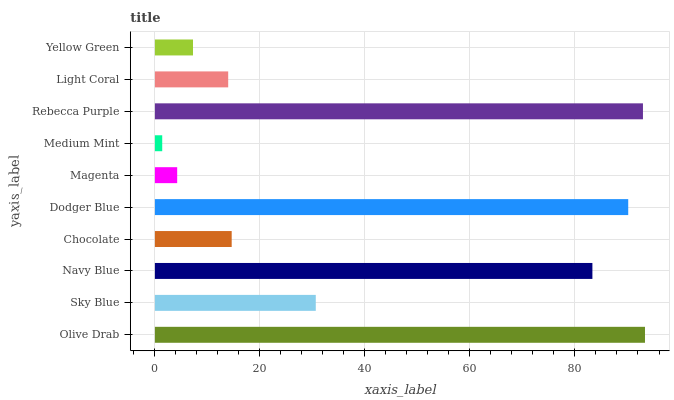Is Medium Mint the minimum?
Answer yes or no. Yes. Is Olive Drab the maximum?
Answer yes or no. Yes. Is Sky Blue the minimum?
Answer yes or no. No. Is Sky Blue the maximum?
Answer yes or no. No. Is Olive Drab greater than Sky Blue?
Answer yes or no. Yes. Is Sky Blue less than Olive Drab?
Answer yes or no. Yes. Is Sky Blue greater than Olive Drab?
Answer yes or no. No. Is Olive Drab less than Sky Blue?
Answer yes or no. No. Is Sky Blue the high median?
Answer yes or no. Yes. Is Chocolate the low median?
Answer yes or no. Yes. Is Magenta the high median?
Answer yes or no. No. Is Rebecca Purple the low median?
Answer yes or no. No. 